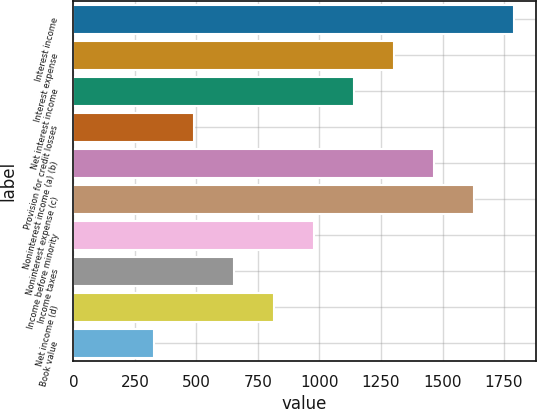Convert chart. <chart><loc_0><loc_0><loc_500><loc_500><bar_chart><fcel>Interest income<fcel>Interest expense<fcel>Net interest income<fcel>Provision for credit losses<fcel>Noninterest income (a) (b)<fcel>Noninterest expense (c)<fcel>Income before minority<fcel>Income taxes<fcel>Net income (d)<fcel>Book value<nl><fcel>1789.57<fcel>1301.83<fcel>1139.25<fcel>488.93<fcel>1464.41<fcel>1626.99<fcel>976.67<fcel>651.51<fcel>814.09<fcel>326.35<nl></chart> 